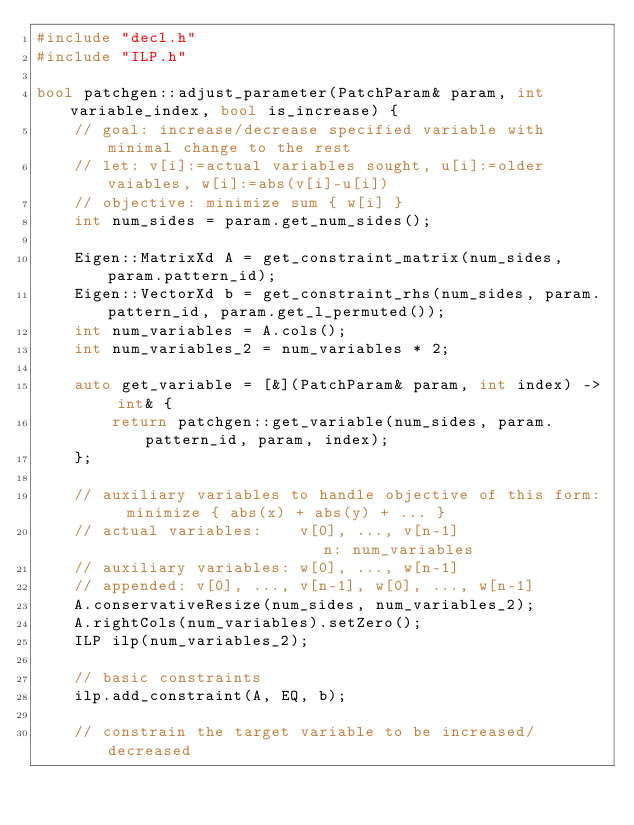<code> <loc_0><loc_0><loc_500><loc_500><_C++_>#include "decl.h"
#include "ILP.h"

bool patchgen::adjust_parameter(PatchParam& param, int variable_index, bool is_increase) {
    // goal: increase/decrease specified variable with minimal change to the rest
    // let: v[i]:=actual variables sought, u[i]:=older vaiables, w[i]:=abs(v[i]-u[i])
    // objective: minimize sum { w[i] }
    int num_sides = param.get_num_sides();

    Eigen::MatrixXd A = get_constraint_matrix(num_sides, param.pattern_id);
    Eigen::VectorXd b = get_constraint_rhs(num_sides, param.pattern_id, param.get_l_permuted());
    int num_variables = A.cols();
    int num_variables_2 = num_variables * 2;

    auto get_variable = [&](PatchParam& param, int index) -> int& {
        return patchgen::get_variable(num_sides, param.pattern_id, param, index);
    };
        
    // auxiliary variables to handle objective of this form:  minimize { abs(x) + abs(y) + ... }
    // actual variables:    v[0], ..., v[n-1]                        n: num_variables
    // auxiliary variables: w[0], ..., w[n-1]
    // appended: v[0], ..., v[n-1], w[0], ..., w[n-1]
    A.conservativeResize(num_sides, num_variables_2);
    A.rightCols(num_variables).setZero();
    ILP ilp(num_variables_2);

    // basic constraints
    ilp.add_constraint(A, EQ, b);

    // constrain the target variable to be increased/decreased</code> 